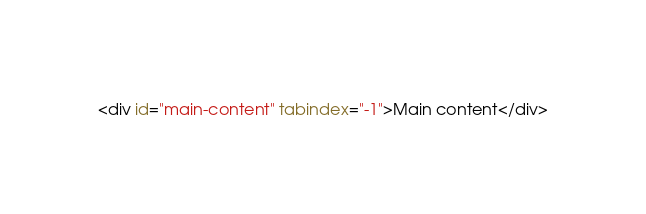<code> <loc_0><loc_0><loc_500><loc_500><_HTML_><div id="main-content" tabindex="-1">Main content</div>
</code> 